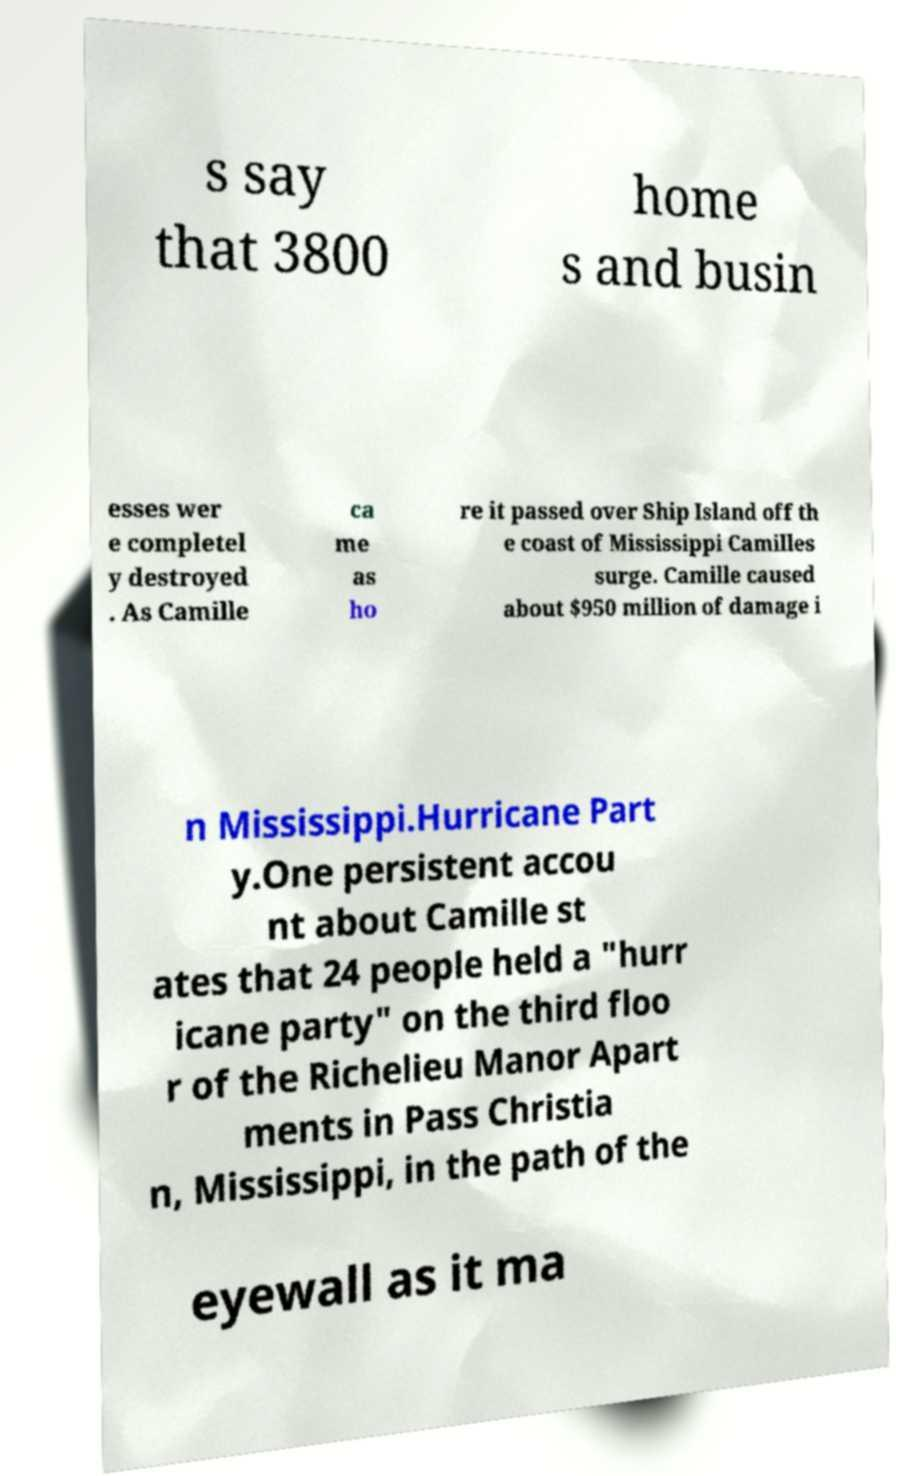Please read and relay the text visible in this image. What does it say? s say that 3800 home s and busin esses wer e completel y destroyed . As Camille ca me as ho re it passed over Ship Island off th e coast of Mississippi Camilles surge. Camille caused about $950 million of damage i n Mississippi.Hurricane Part y.One persistent accou nt about Camille st ates that 24 people held a "hurr icane party" on the third floo r of the Richelieu Manor Apart ments in Pass Christia n, Mississippi, in the path of the eyewall as it ma 